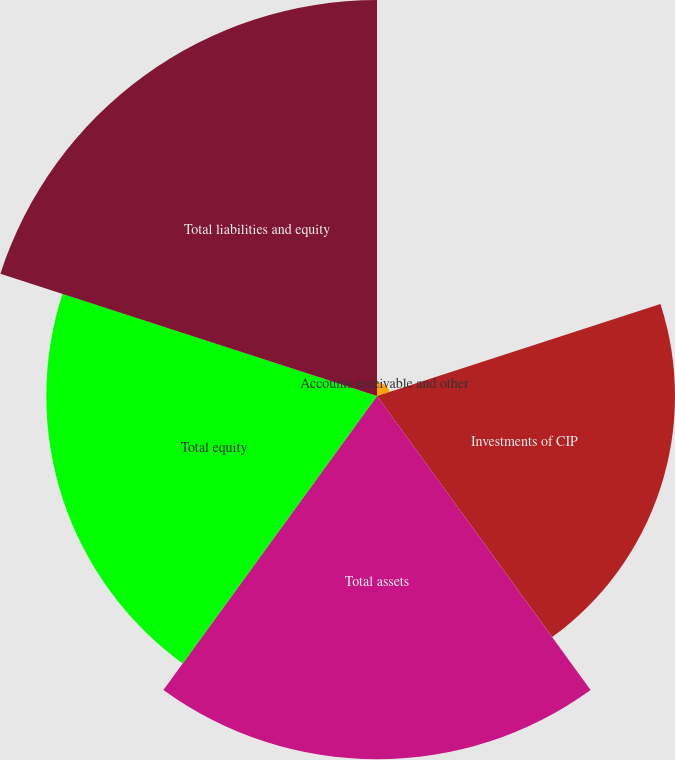Convert chart. <chart><loc_0><loc_0><loc_500><loc_500><pie_chart><fcel>Accounts receivable and other<fcel>Investments of CIP<fcel>Total assets<fcel>Total equity<fcel>Total liabilities and equity<nl><fcel>0.97%<fcel>21.26%<fcel>25.92%<fcel>23.59%<fcel>28.25%<nl></chart> 